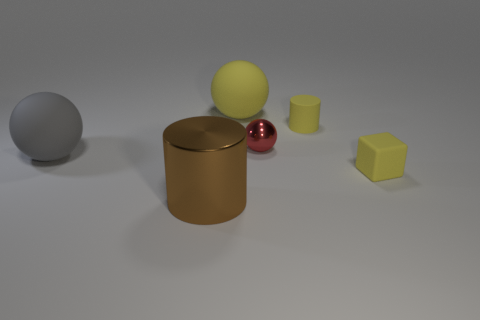What number of cylinders have the same material as the cube?
Your answer should be very brief. 1. Is the number of brown objects that are to the right of the metal cylinder less than the number of brown things?
Your response must be concise. Yes. What number of big shiny spheres are there?
Provide a succinct answer. 0. What number of rubber blocks are the same color as the large metallic cylinder?
Ensure brevity in your answer.  0. Do the tiny red thing and the large yellow rubber thing have the same shape?
Keep it short and to the point. Yes. There is a cylinder behind the rubber object on the left side of the large yellow thing; how big is it?
Give a very brief answer. Small. Is there a brown object of the same size as the red shiny thing?
Your answer should be very brief. No. Does the metal object in front of the small yellow cube have the same size as the metal thing that is behind the big gray matte ball?
Your answer should be compact. No. There is a metallic thing that is behind the yellow object that is in front of the big gray ball; what shape is it?
Your response must be concise. Sphere. How many balls are in front of the yellow rubber ball?
Your response must be concise. 2. 